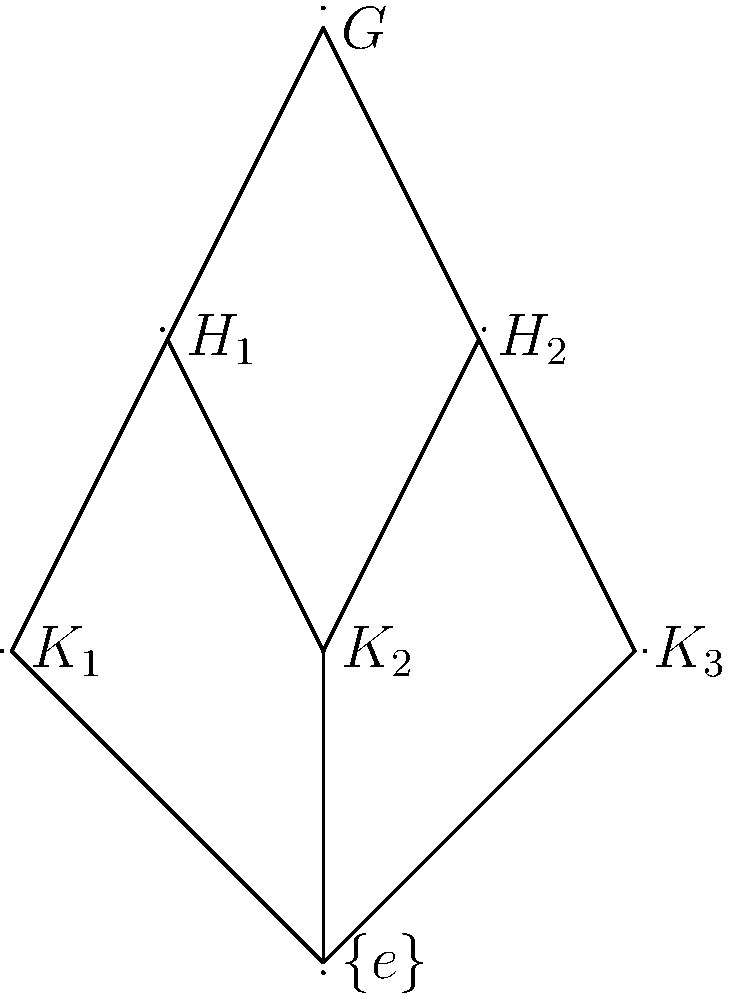Given the subgroup lattice diagram of a group $G$, determine the number of maximal subgroups of $G$ and explain how this relates to the concept of minimal normal subgroups in the context of low-level programming for hardware devices. To answer this question, let's follow these steps:

1. Analyze the subgroup lattice diagram:
   - The diagram shows the group $G$ at the top, with various subgroups below it.
   - The lines connecting the nodes represent subset relations.

2. Identify the maximal subgroups:
   - Maximal subgroups are the largest proper subgroups of $G$.
   - They are directly connected to $G$ in the lattice diagram.
   - In this case, we can see that $H_1$ and $H_2$ are directly connected to $G$.

3. Count the maximal subgroups:
   - There are two maximal subgroups: $H_1$ and $H_2$.

4. Relate to minimal normal subgroups:
   - Minimal normal subgroups are the smallest non-trivial normal subgroups of $G$.
   - They are dual to maximal subgroups in group theory.
   - In the context of low-level programming for hardware devices:
     a. Maximal subgroups can represent the highest-level abstractions of hardware components.
     b. Minimal normal subgroups can represent the most basic, indivisible operations or states.

5. Application to low-level programming:
   - In hardware programming, understanding the hierarchy of operations is crucial.
   - Maximal subgroups ($H_1$ and $H_2$) could represent two main hardware modules or instruction sets.
   - The subgroups below them ($K_1$, $K_2$, $K_3$) might represent more specific operations or states.
   - The trivial subgroup $\{e\}$ at the bottom could represent the most basic state or operation.

6. Importance in hardware design:
   - This hierarchical structure helps in organizing and optimizing low-level code.
   - It allows for efficient partitioning of tasks and resources in hardware programming.
   - Understanding the relationships between different levels of abstraction is key to writing efficient, modular code for hardware devices.
Answer: 2 maximal subgroups; represents highest-level hardware abstractions 